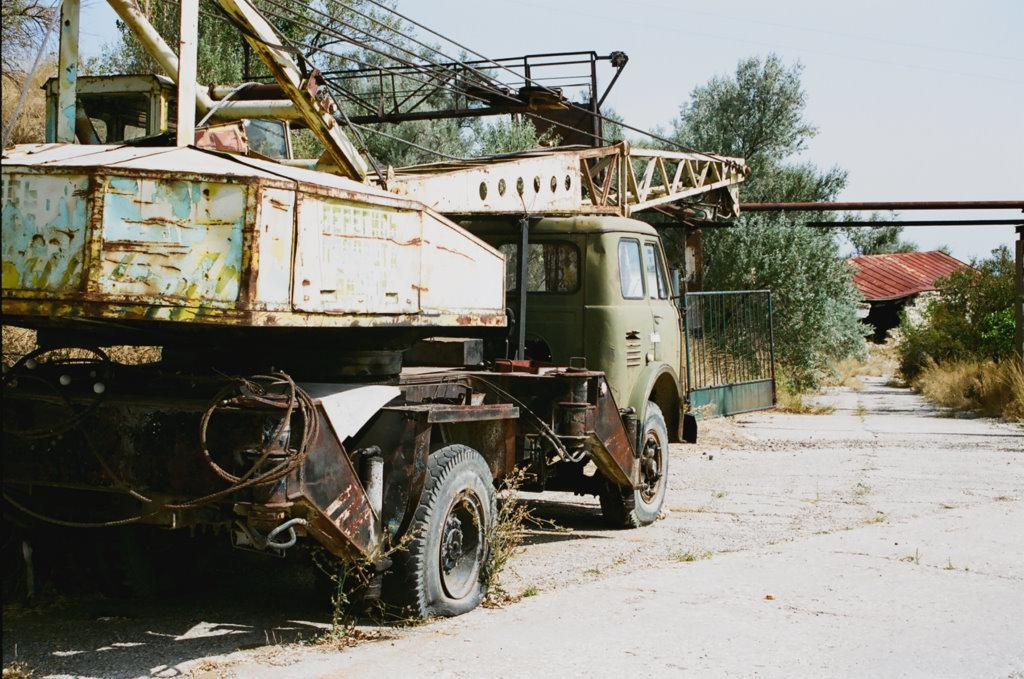What is the condition of the vehicle in the image? The vehicle in the image is scraped. What is blocking the vehicle in the image? There is a gate in front of the vehicle. What type of natural elements can be seen in the image? There are trees and plants around the area. How old is the daughter of the vehicle's owner in the image? There is no mention of a daughter or an owner in the image, so we cannot determine the age of the daughter. 